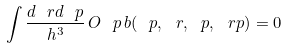<formula> <loc_0><loc_0><loc_500><loc_500>\int \frac { d \ r d \ p } { h ^ { 3 } } \, O _ { \ } p \, b ( \ p , \ r , \ p , \ r p ) = 0</formula> 